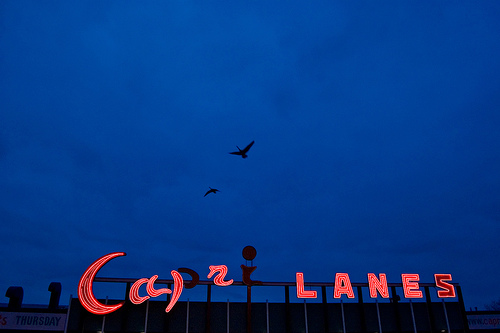<image>
Is there a bird in the sky? Yes. The bird is contained within or inside the sky, showing a containment relationship. 